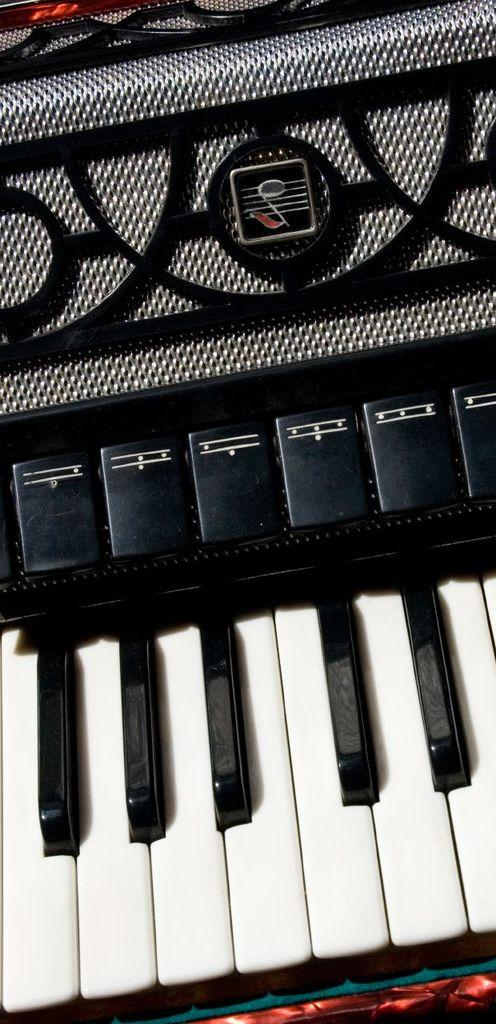What is the main object in the image? There is a piano in the image. Can you see any ants crawling on the piano in the image? There are no ants visible on the piano in the image. What type of balance does the piano have in the image? The image does not provide information about the balance of the piano. 